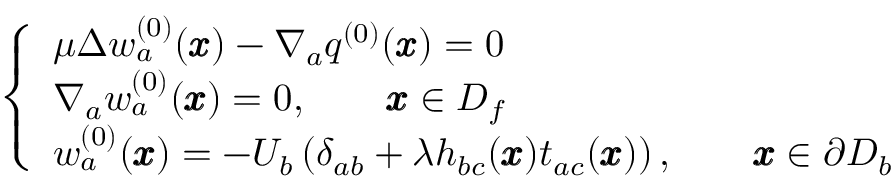<formula> <loc_0><loc_0><loc_500><loc_500>\left \{ \begin{array} { l l } { \mu \Delta w _ { a } ^ { ( 0 ) } ( { \pm b x } ) - \nabla _ { a } q ^ { ( 0 ) } ( { \pm b x } ) = 0 } \\ { \nabla _ { a } w _ { a } ^ { ( 0 ) } ( { \pm b x } ) = 0 , \quad { \pm b x } \in D _ { f } } \\ { w _ { a } ^ { ( 0 ) } ( \pm b x ) = - U _ { b } \left ( \delta _ { a b } + { \lambda } h _ { b c } ( { \pm b x } ) t _ { a c } ( { \pm b x } ) \right ) , \quad { \pm b x } \in \partial D _ { b } } \end{array}</formula> 